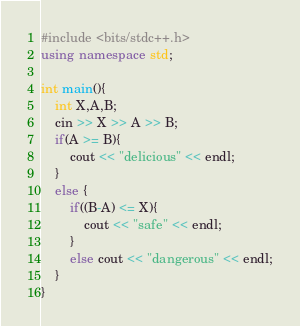Convert code to text. <code><loc_0><loc_0><loc_500><loc_500><_C++_>#include <bits/stdc++.h>
using namespace std;
 
int main(){
    int X,A,B;
    cin >> X >> A >> B;
    if(A >= B){
        cout << "delicious" << endl;
    }
    else {
        if((B-A) <= X){
            cout << "safe" << endl;
        }
        else cout << "dangerous" << endl;
    }
}</code> 